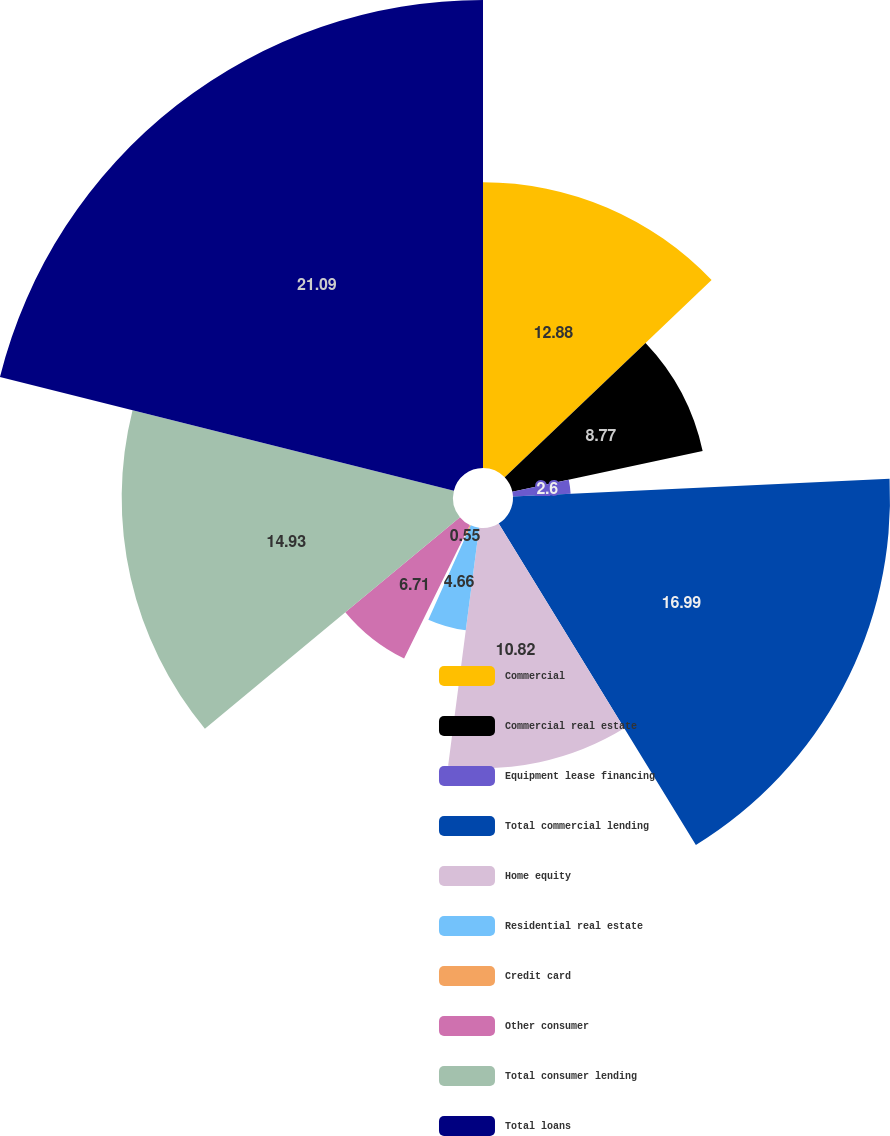Convert chart. <chart><loc_0><loc_0><loc_500><loc_500><pie_chart><fcel>Commercial<fcel>Commercial real estate<fcel>Equipment lease financing<fcel>Total commercial lending<fcel>Home equity<fcel>Residential real estate<fcel>Credit card<fcel>Other consumer<fcel>Total consumer lending<fcel>Total loans<nl><fcel>12.88%<fcel>8.77%<fcel>2.6%<fcel>16.99%<fcel>10.82%<fcel>4.66%<fcel>0.55%<fcel>6.71%<fcel>14.93%<fcel>21.09%<nl></chart> 